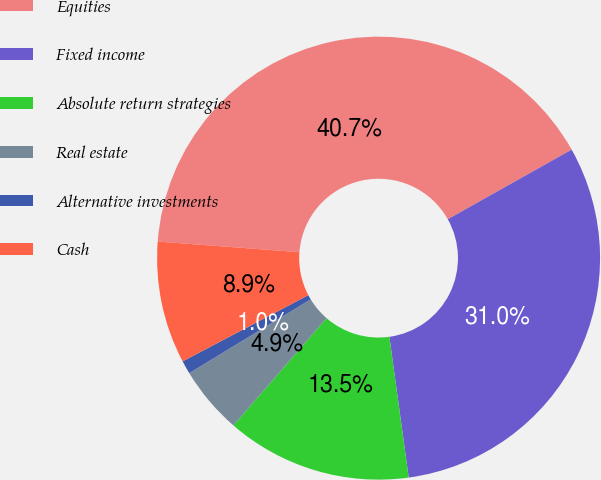<chart> <loc_0><loc_0><loc_500><loc_500><pie_chart><fcel>Equities<fcel>Fixed income<fcel>Absolute return strategies<fcel>Real estate<fcel>Alternative investments<fcel>Cash<nl><fcel>40.66%<fcel>30.98%<fcel>13.55%<fcel>4.94%<fcel>0.97%<fcel>8.91%<nl></chart> 